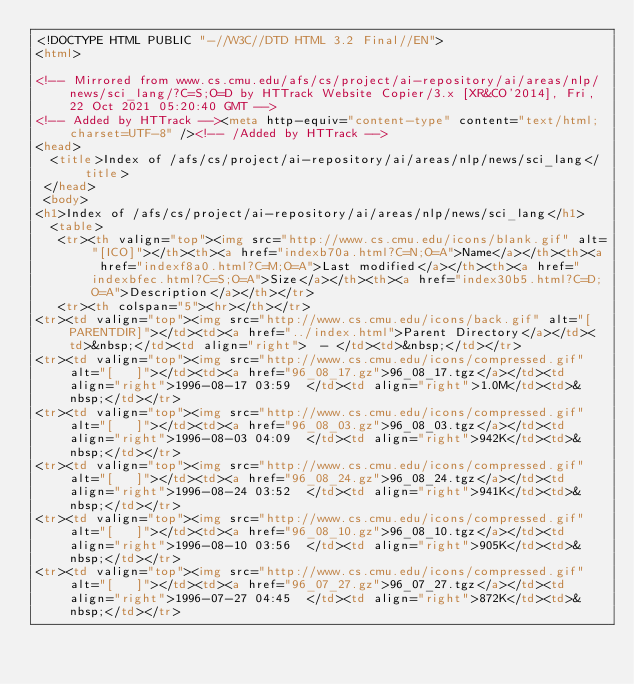<code> <loc_0><loc_0><loc_500><loc_500><_HTML_><!DOCTYPE HTML PUBLIC "-//W3C//DTD HTML 3.2 Final//EN">
<html>
 
<!-- Mirrored from www.cs.cmu.edu/afs/cs/project/ai-repository/ai/areas/nlp/news/sci_lang/?C=S;O=D by HTTrack Website Copier/3.x [XR&CO'2014], Fri, 22 Oct 2021 05:20:40 GMT -->
<!-- Added by HTTrack --><meta http-equiv="content-type" content="text/html;charset=UTF-8" /><!-- /Added by HTTrack -->
<head>
  <title>Index of /afs/cs/project/ai-repository/ai/areas/nlp/news/sci_lang</title>
 </head>
 <body>
<h1>Index of /afs/cs/project/ai-repository/ai/areas/nlp/news/sci_lang</h1>
  <table>
   <tr><th valign="top"><img src="http://www.cs.cmu.edu/icons/blank.gif" alt="[ICO]"></th><th><a href="indexb70a.html?C=N;O=A">Name</a></th><th><a href="indexf8a0.html?C=M;O=A">Last modified</a></th><th><a href="indexbfec.html?C=S;O=A">Size</a></th><th><a href="index30b5.html?C=D;O=A">Description</a></th></tr>
   <tr><th colspan="5"><hr></th></tr>
<tr><td valign="top"><img src="http://www.cs.cmu.edu/icons/back.gif" alt="[PARENTDIR]"></td><td><a href="../index.html">Parent Directory</a></td><td>&nbsp;</td><td align="right">  - </td><td>&nbsp;</td></tr>
<tr><td valign="top"><img src="http://www.cs.cmu.edu/icons/compressed.gif" alt="[   ]"></td><td><a href="96_08_17.gz">96_08_17.tgz</a></td><td align="right">1996-08-17 03:59  </td><td align="right">1.0M</td><td>&nbsp;</td></tr>
<tr><td valign="top"><img src="http://www.cs.cmu.edu/icons/compressed.gif" alt="[   ]"></td><td><a href="96_08_03.gz">96_08_03.tgz</a></td><td align="right">1996-08-03 04:09  </td><td align="right">942K</td><td>&nbsp;</td></tr>
<tr><td valign="top"><img src="http://www.cs.cmu.edu/icons/compressed.gif" alt="[   ]"></td><td><a href="96_08_24.gz">96_08_24.tgz</a></td><td align="right">1996-08-24 03:52  </td><td align="right">941K</td><td>&nbsp;</td></tr>
<tr><td valign="top"><img src="http://www.cs.cmu.edu/icons/compressed.gif" alt="[   ]"></td><td><a href="96_08_10.gz">96_08_10.tgz</a></td><td align="right">1996-08-10 03:56  </td><td align="right">905K</td><td>&nbsp;</td></tr>
<tr><td valign="top"><img src="http://www.cs.cmu.edu/icons/compressed.gif" alt="[   ]"></td><td><a href="96_07_27.gz">96_07_27.tgz</a></td><td align="right">1996-07-27 04:45  </td><td align="right">872K</td><td>&nbsp;</td></tr></code> 